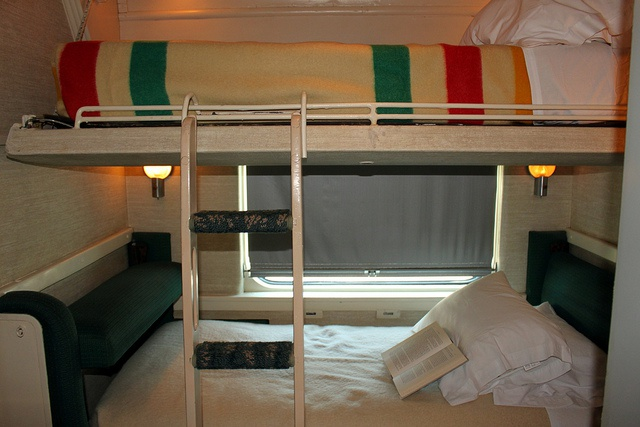Describe the objects in this image and their specific colors. I can see bed in maroon, black, and gray tones, bed in maroon, gray, and brown tones, and book in maroon, gray, and darkgray tones in this image. 